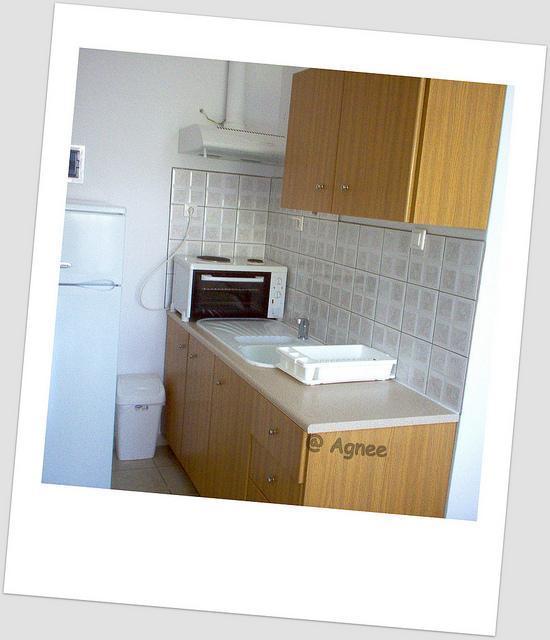How many microwaves are there?
Give a very brief answer. 1. How many trains on the track?
Give a very brief answer. 0. 